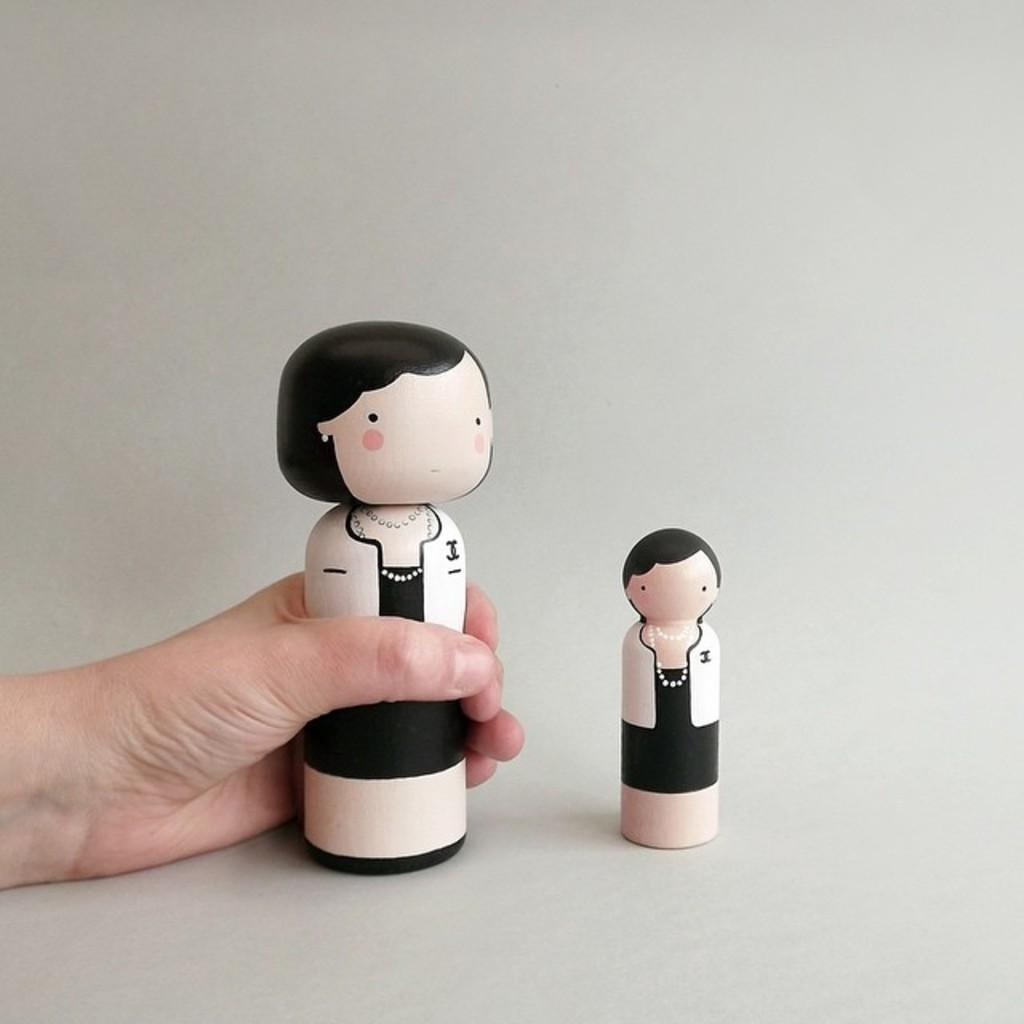What is the main subject of the image? The main subject of the image is a human hand holding an object. What can be seen in the background of the image? The background of the image is white. What type of bomb is being defused by the boy in the image? There is no boy or bomb present in the image; it features a human hand holding an object against a white background. 